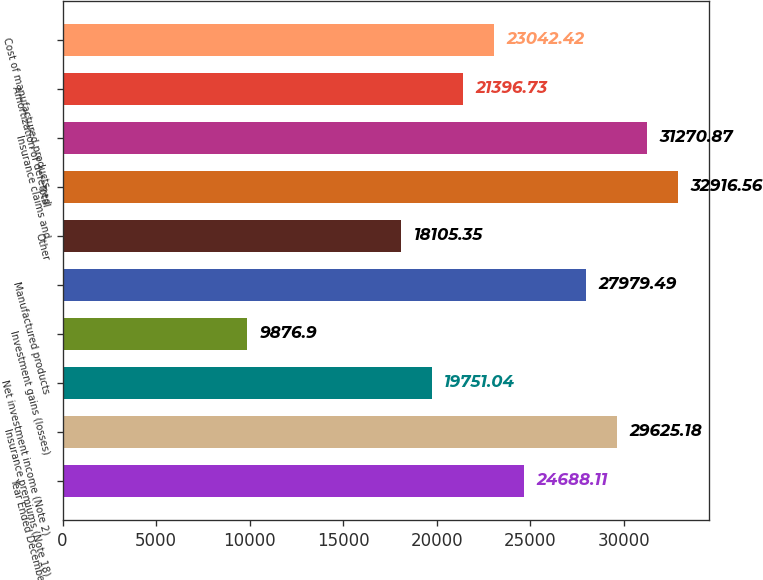Convert chart. <chart><loc_0><loc_0><loc_500><loc_500><bar_chart><fcel>Year Ended December 31<fcel>Insurance premiums (Note 18)<fcel>Net investment income (Note 2)<fcel>Investment gains (losses)<fcel>Manufactured products<fcel>Other<fcel>Total<fcel>Insurance claims and<fcel>Amortization of deferred<fcel>Cost of manufactured products<nl><fcel>24688.1<fcel>29625.2<fcel>19751<fcel>9876.9<fcel>27979.5<fcel>18105.3<fcel>32916.6<fcel>31270.9<fcel>21396.7<fcel>23042.4<nl></chart> 